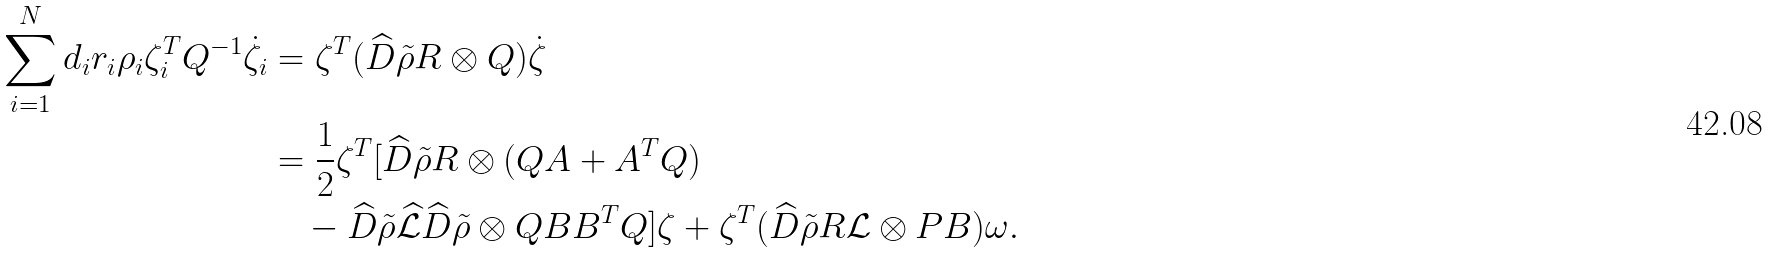Convert formula to latex. <formula><loc_0><loc_0><loc_500><loc_500>\sum _ { i = 1 } ^ { N } d _ { i } r _ { i } \rho _ { i } \zeta _ { i } ^ { T } Q ^ { - 1 } \dot { \zeta } _ { i } & = \zeta ^ { T } ( \widehat { D } \tilde { \rho } R \otimes Q ) \dot { \zeta } \\ & = \frac { 1 } { 2 } \zeta ^ { T } [ \widehat { D } \tilde { \rho } R \otimes ( Q A + A ^ { T } Q ) \\ & \quad - \widehat { D } \tilde { \rho } \widehat { \mathcal { L } } \widehat { D } \tilde { \rho } \otimes Q B B ^ { T } Q ] \zeta + \zeta ^ { T } ( \widehat { D } \tilde { \rho } R \mathcal { L } \otimes P B ) \omega .</formula> 